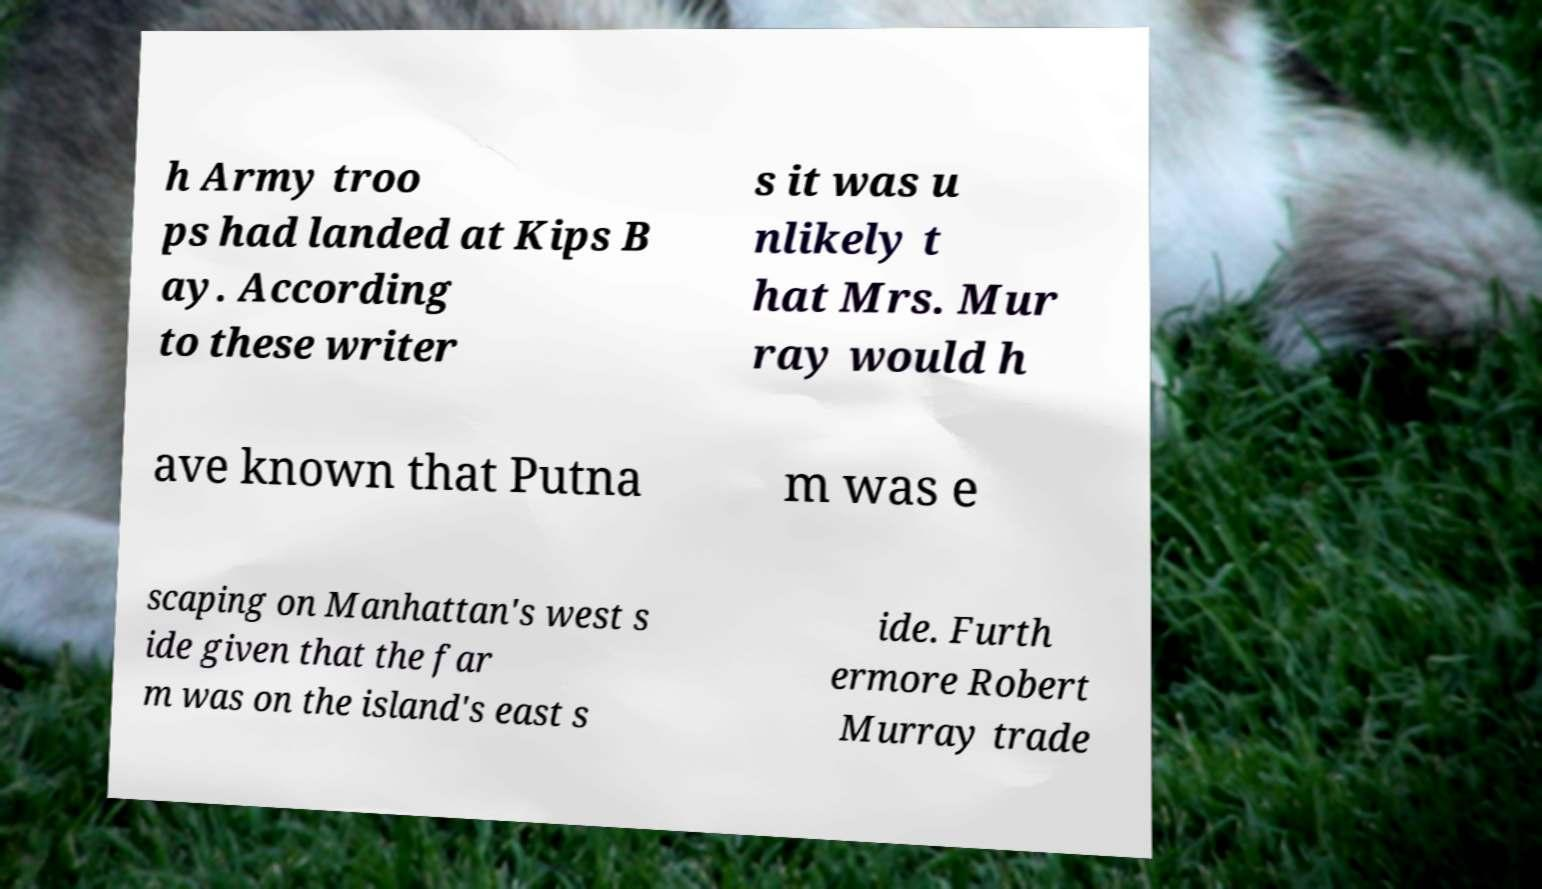Please read and relay the text visible in this image. What does it say? h Army troo ps had landed at Kips B ay. According to these writer s it was u nlikely t hat Mrs. Mur ray would h ave known that Putna m was e scaping on Manhattan's west s ide given that the far m was on the island's east s ide. Furth ermore Robert Murray trade 